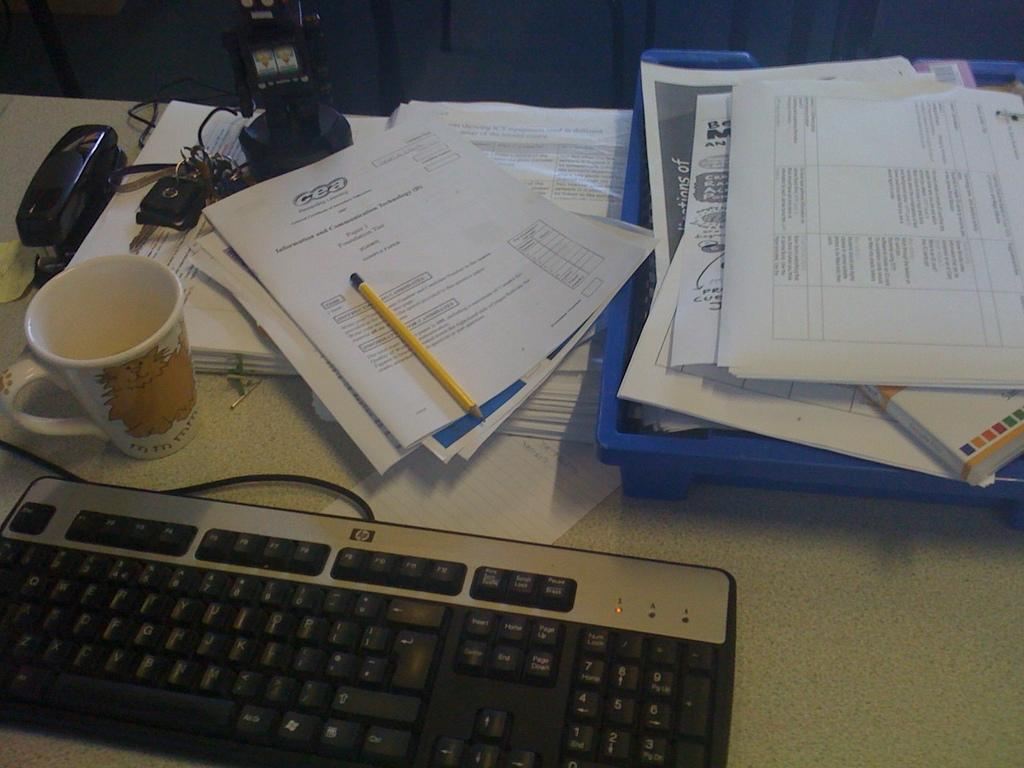What is the main object on the table in the image? There is a keyboard in the image. What else can be seen on the table besides the keyboard? There is a cup, papers, and a pencil in the image. What might be used for writing in the image? The pencil in the image can be used for writing. What other objects are present on the table in the image? There are other objects on the table in the image, but their specific details are not mentioned in the provided facts. How does the temper of the person using the keyboard affect the rainstorm outside in the image? There is no rainstorm present in the image, and the temper of the person using the keyboard cannot be determined from the image. 